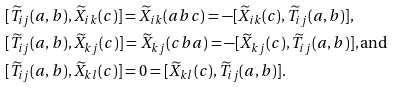Convert formula to latex. <formula><loc_0><loc_0><loc_500><loc_500>& [ \widetilde { T } _ { i j } ( a , b ) , \widetilde { X } _ { i k } ( c ) ] = \widetilde { X } _ { i k } ( a b c ) = - [ \widetilde { X } _ { i k } ( c ) , \widetilde { T } _ { i j } ( a , b ) ] , \\ & [ \widetilde { T } _ { i j } ( a , b ) , \widetilde { X } _ { k j } ( c ) ] = \widetilde { X } _ { k j } ( c b a ) = - [ \widetilde { X } _ { k j } ( c ) , \widetilde { T } _ { i j } ( a , b ) ] , \text {and} \\ & [ \widetilde { T } _ { i j } ( a , b ) , \widetilde { X } _ { k l } ( c ) ] = 0 = [ \widetilde { X } _ { k l } ( c ) , \widetilde { T } _ { i j } ( a , b ) ] .</formula> 